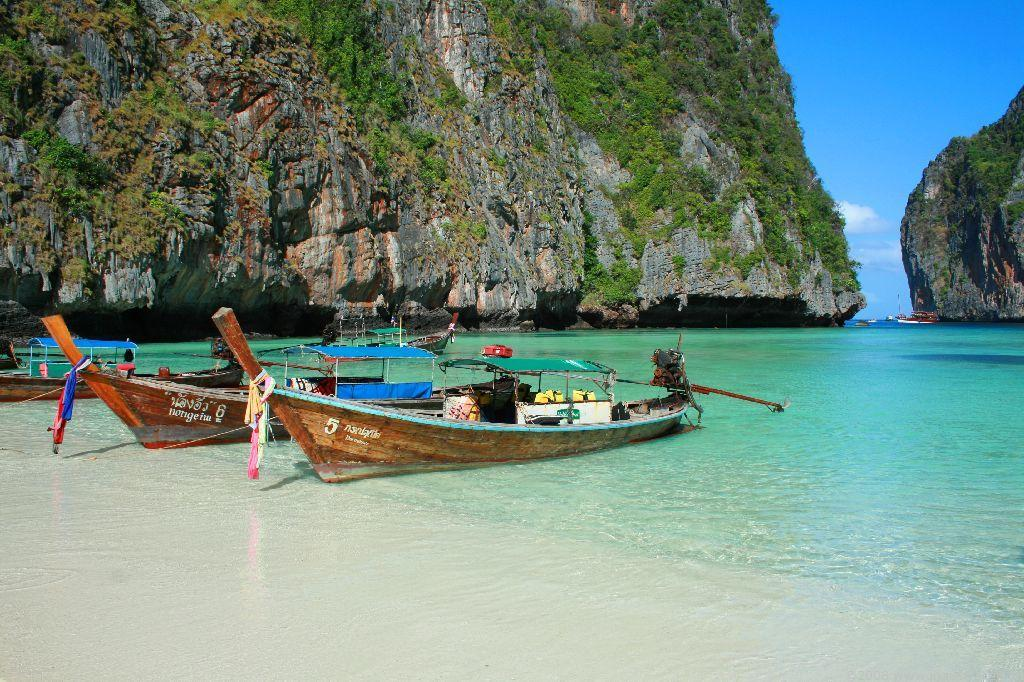<image>
Render a clear and concise summary of the photo. Two boats parked by the waters and says "Notigeim" on it. 